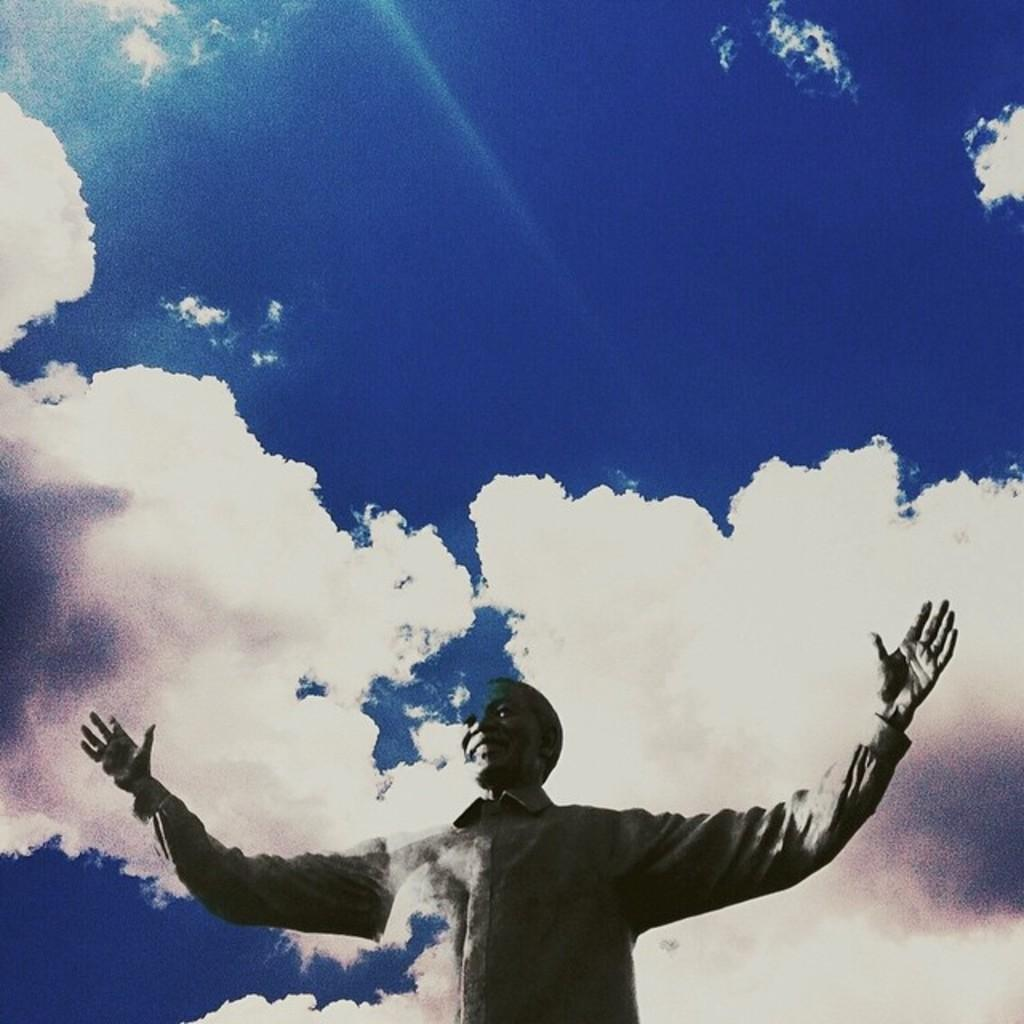Who or what is the main subject in the image? There is a person in the image. What is the person wearing? The person is wearing a dress. What can be seen in the background of the image? There are clouds and the sky visible in the background of the image. What type of truck is parked next to the person in the image? There is no truck present in the image; it only features a person wearing a dress with a background of clouds and the sky. 